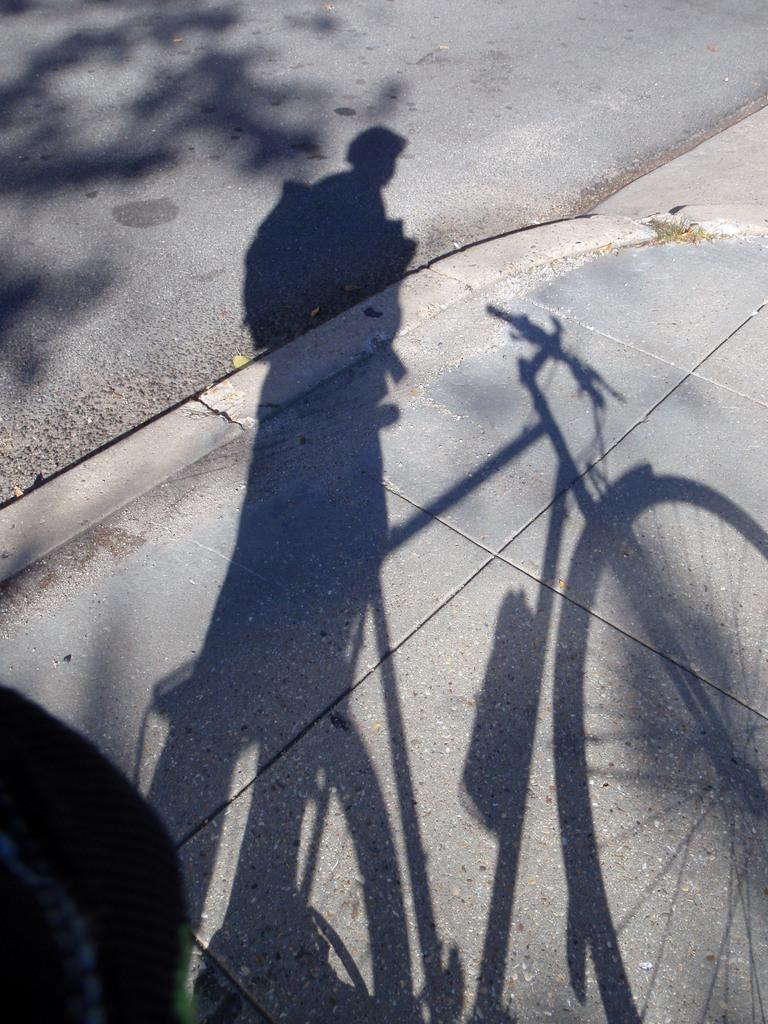What can be seen in the image that is not a part of the natural environment in the image? There is a bicycle in the image. What is casting a shadow in the image? There is a shadow of a person in the image. What type of plant is present in the image? There is a tree in the image. What is located at the left side of the image? There is an object at the left side of the image. What shape is the low-flying aircraft in the image? There is no aircraft present in the image; it only features a shadow of a person, a bicycle, a tree, and an object at the left side. 